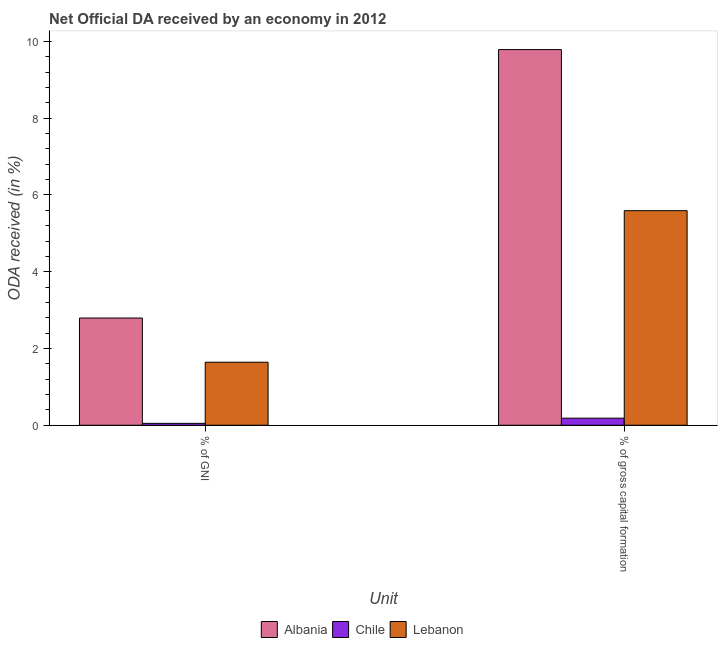How many groups of bars are there?
Provide a short and direct response. 2. Are the number of bars per tick equal to the number of legend labels?
Ensure brevity in your answer.  Yes. How many bars are there on the 2nd tick from the right?
Offer a terse response. 3. What is the label of the 2nd group of bars from the left?
Provide a short and direct response. % of gross capital formation. What is the oda received as percentage of gni in Lebanon?
Your response must be concise. 1.64. Across all countries, what is the maximum oda received as percentage of gni?
Ensure brevity in your answer.  2.79. Across all countries, what is the minimum oda received as percentage of gni?
Give a very brief answer. 0.05. In which country was the oda received as percentage of gni maximum?
Offer a terse response. Albania. In which country was the oda received as percentage of gross capital formation minimum?
Keep it short and to the point. Chile. What is the total oda received as percentage of gross capital formation in the graph?
Offer a very short reply. 15.56. What is the difference between the oda received as percentage of gross capital formation in Chile and that in Lebanon?
Your response must be concise. -5.41. What is the difference between the oda received as percentage of gni in Albania and the oda received as percentage of gross capital formation in Chile?
Give a very brief answer. 2.61. What is the average oda received as percentage of gross capital formation per country?
Ensure brevity in your answer.  5.19. What is the difference between the oda received as percentage of gni and oda received as percentage of gross capital formation in Lebanon?
Keep it short and to the point. -3.95. In how many countries, is the oda received as percentage of gni greater than 1.6 %?
Offer a very short reply. 2. What is the ratio of the oda received as percentage of gni in Albania to that in Chile?
Provide a short and direct response. 56.83. Is the oda received as percentage of gni in Chile less than that in Lebanon?
Offer a terse response. Yes. What does the 2nd bar from the left in % of gross capital formation represents?
Ensure brevity in your answer.  Chile. What does the 3rd bar from the right in % of gross capital formation represents?
Offer a terse response. Albania. How many bars are there?
Make the answer very short. 6. What is the difference between two consecutive major ticks on the Y-axis?
Offer a terse response. 2. Does the graph contain grids?
Provide a short and direct response. No. How many legend labels are there?
Give a very brief answer. 3. What is the title of the graph?
Give a very brief answer. Net Official DA received by an economy in 2012. Does "Barbados" appear as one of the legend labels in the graph?
Offer a very short reply. No. What is the label or title of the X-axis?
Make the answer very short. Unit. What is the label or title of the Y-axis?
Provide a succinct answer. ODA received (in %). What is the ODA received (in %) of Albania in % of GNI?
Offer a terse response. 2.79. What is the ODA received (in %) in Chile in % of GNI?
Your response must be concise. 0.05. What is the ODA received (in %) of Lebanon in % of GNI?
Ensure brevity in your answer.  1.64. What is the ODA received (in %) in Albania in % of gross capital formation?
Give a very brief answer. 9.79. What is the ODA received (in %) of Chile in % of gross capital formation?
Your response must be concise. 0.18. What is the ODA received (in %) in Lebanon in % of gross capital formation?
Provide a short and direct response. 5.59. Across all Unit, what is the maximum ODA received (in %) of Albania?
Provide a short and direct response. 9.79. Across all Unit, what is the maximum ODA received (in %) of Chile?
Keep it short and to the point. 0.18. Across all Unit, what is the maximum ODA received (in %) in Lebanon?
Your answer should be compact. 5.59. Across all Unit, what is the minimum ODA received (in %) in Albania?
Make the answer very short. 2.79. Across all Unit, what is the minimum ODA received (in %) in Chile?
Your answer should be compact. 0.05. Across all Unit, what is the minimum ODA received (in %) in Lebanon?
Give a very brief answer. 1.64. What is the total ODA received (in %) in Albania in the graph?
Your response must be concise. 12.58. What is the total ODA received (in %) in Chile in the graph?
Your answer should be very brief. 0.23. What is the total ODA received (in %) of Lebanon in the graph?
Provide a succinct answer. 7.23. What is the difference between the ODA received (in %) of Albania in % of GNI and that in % of gross capital formation?
Provide a short and direct response. -6.99. What is the difference between the ODA received (in %) of Chile in % of GNI and that in % of gross capital formation?
Offer a very short reply. -0.14. What is the difference between the ODA received (in %) of Lebanon in % of GNI and that in % of gross capital formation?
Keep it short and to the point. -3.95. What is the difference between the ODA received (in %) in Albania in % of GNI and the ODA received (in %) in Chile in % of gross capital formation?
Keep it short and to the point. 2.61. What is the difference between the ODA received (in %) of Albania in % of GNI and the ODA received (in %) of Lebanon in % of gross capital formation?
Make the answer very short. -2.8. What is the difference between the ODA received (in %) in Chile in % of GNI and the ODA received (in %) in Lebanon in % of gross capital formation?
Your response must be concise. -5.54. What is the average ODA received (in %) in Albania per Unit?
Keep it short and to the point. 6.29. What is the average ODA received (in %) in Chile per Unit?
Provide a succinct answer. 0.12. What is the average ODA received (in %) in Lebanon per Unit?
Offer a very short reply. 3.62. What is the difference between the ODA received (in %) in Albania and ODA received (in %) in Chile in % of GNI?
Give a very brief answer. 2.74. What is the difference between the ODA received (in %) of Albania and ODA received (in %) of Lebanon in % of GNI?
Offer a very short reply. 1.15. What is the difference between the ODA received (in %) of Chile and ODA received (in %) of Lebanon in % of GNI?
Offer a terse response. -1.59. What is the difference between the ODA received (in %) of Albania and ODA received (in %) of Chile in % of gross capital formation?
Provide a short and direct response. 9.6. What is the difference between the ODA received (in %) in Albania and ODA received (in %) in Lebanon in % of gross capital formation?
Ensure brevity in your answer.  4.2. What is the difference between the ODA received (in %) of Chile and ODA received (in %) of Lebanon in % of gross capital formation?
Provide a succinct answer. -5.41. What is the ratio of the ODA received (in %) of Albania in % of GNI to that in % of gross capital formation?
Offer a terse response. 0.29. What is the ratio of the ODA received (in %) in Chile in % of GNI to that in % of gross capital formation?
Offer a very short reply. 0.27. What is the ratio of the ODA received (in %) of Lebanon in % of GNI to that in % of gross capital formation?
Your answer should be very brief. 0.29. What is the difference between the highest and the second highest ODA received (in %) of Albania?
Provide a succinct answer. 6.99. What is the difference between the highest and the second highest ODA received (in %) of Chile?
Make the answer very short. 0.14. What is the difference between the highest and the second highest ODA received (in %) in Lebanon?
Offer a very short reply. 3.95. What is the difference between the highest and the lowest ODA received (in %) in Albania?
Your answer should be compact. 6.99. What is the difference between the highest and the lowest ODA received (in %) in Chile?
Offer a terse response. 0.14. What is the difference between the highest and the lowest ODA received (in %) in Lebanon?
Your response must be concise. 3.95. 